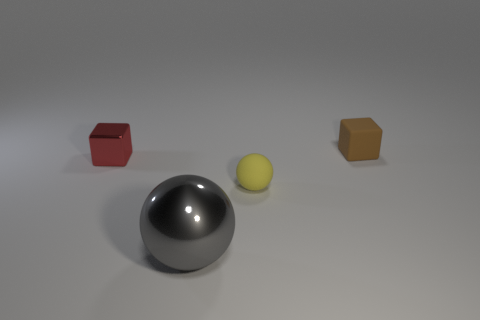What is the material of the yellow object?
Offer a terse response. Rubber. What is the color of the metallic thing that is the same size as the brown matte cube?
Give a very brief answer. Red. Is the tiny brown matte object the same shape as the large thing?
Offer a terse response. No. There is a tiny thing that is behind the tiny sphere and in front of the matte cube; what is its material?
Offer a very short reply. Metal. How big is the yellow sphere?
Your response must be concise. Small. What color is the big object that is the same shape as the small yellow matte object?
Give a very brief answer. Gray. Is there anything else that is the same color as the rubber block?
Give a very brief answer. No. There is a matte thing to the left of the matte block; does it have the same size as the metal thing in front of the red block?
Your answer should be compact. No. Is the number of tiny red blocks behind the tiny shiny thing the same as the number of red shiny blocks that are to the left of the small yellow matte sphere?
Offer a very short reply. No. There is a rubber cube; is it the same size as the sphere left of the tiny yellow object?
Provide a short and direct response. No. 